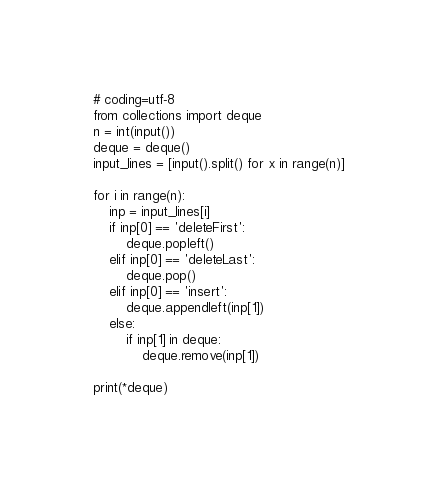<code> <loc_0><loc_0><loc_500><loc_500><_Python_># coding=utf-8
from collections import deque
n = int(input())
deque = deque()
input_lines = [input().split() for x in range(n)]

for i in range(n):
    inp = input_lines[i]
    if inp[0] == 'deleteFirst':
        deque.popleft()
    elif inp[0] == 'deleteLast':
        deque.pop()
    elif inp[0] == 'insert':
        deque.appendleft(inp[1])
    else:
        if inp[1] in deque:
            deque.remove(inp[1])

print(*deque)</code> 